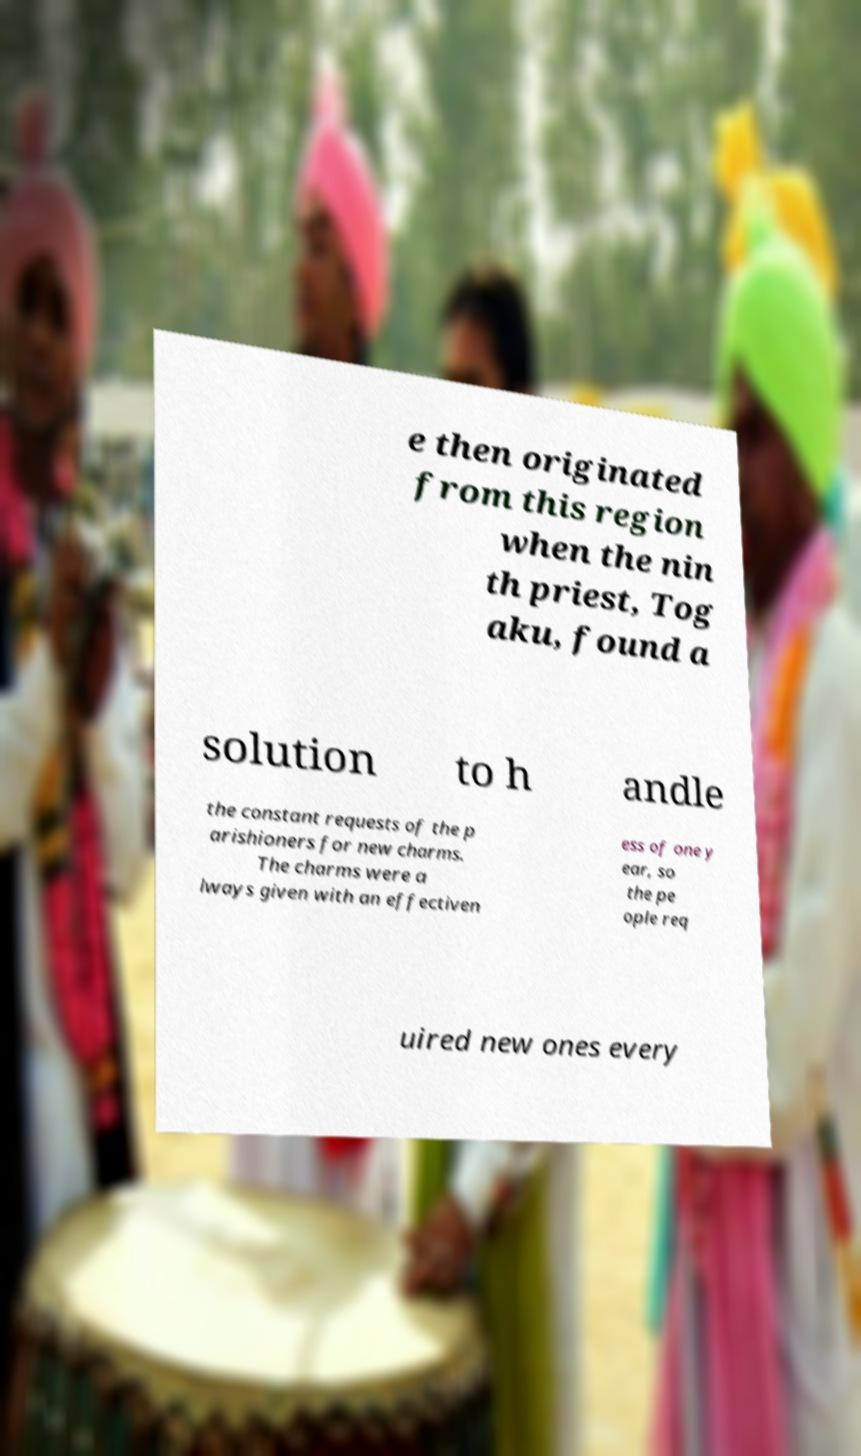Could you assist in decoding the text presented in this image and type it out clearly? e then originated from this region when the nin th priest, Tog aku, found a solution to h andle the constant requests of the p arishioners for new charms. The charms were a lways given with an effectiven ess of one y ear, so the pe ople req uired new ones every 